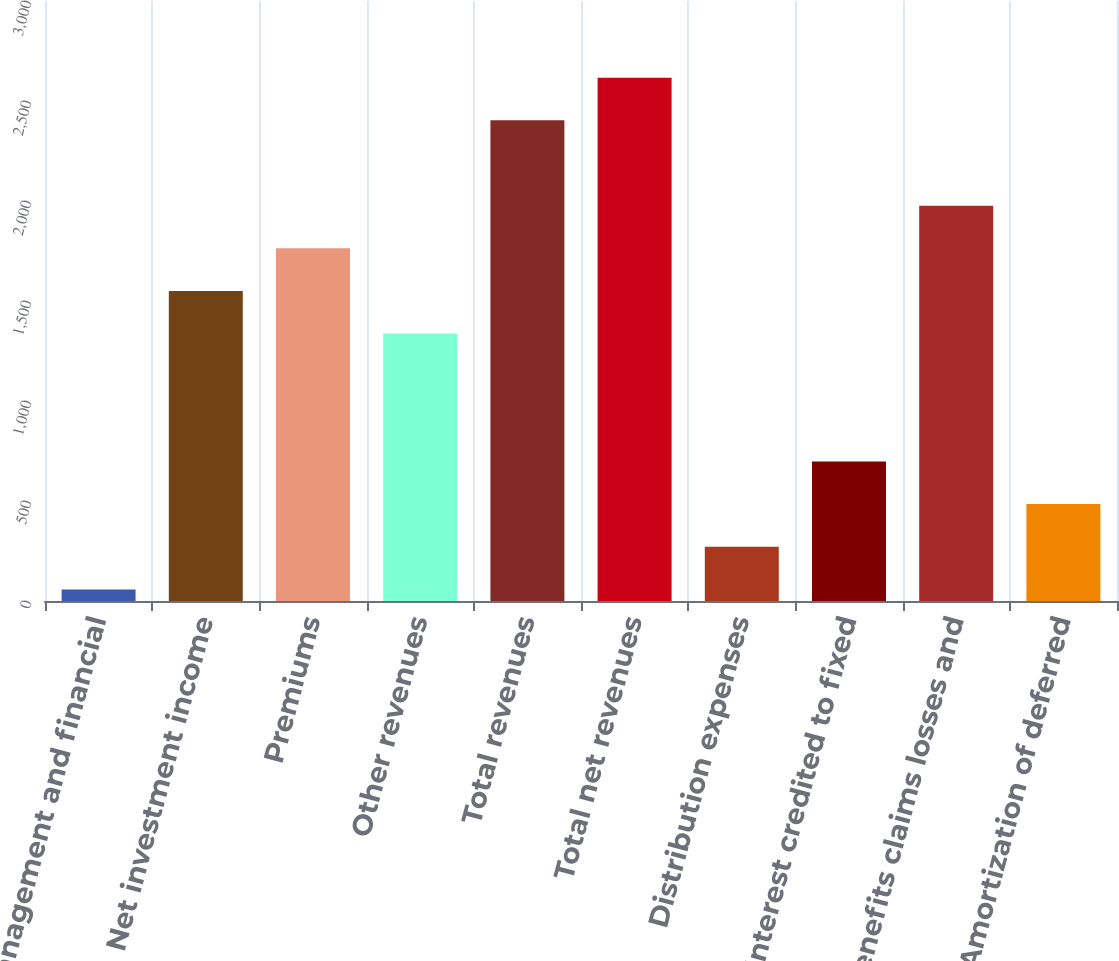Convert chart to OTSL. <chart><loc_0><loc_0><loc_500><loc_500><bar_chart><fcel>Management and financial<fcel>Net investment income<fcel>Premiums<fcel>Other revenues<fcel>Total revenues<fcel>Total net revenues<fcel>Distribution expenses<fcel>Interest credited to fixed<fcel>Benefits claims losses and<fcel>Amortization of deferred<nl><fcel>58<fcel>1550.4<fcel>1763.6<fcel>1337.2<fcel>2403.2<fcel>2616.4<fcel>271.2<fcel>697.6<fcel>1976.8<fcel>484.4<nl></chart> 